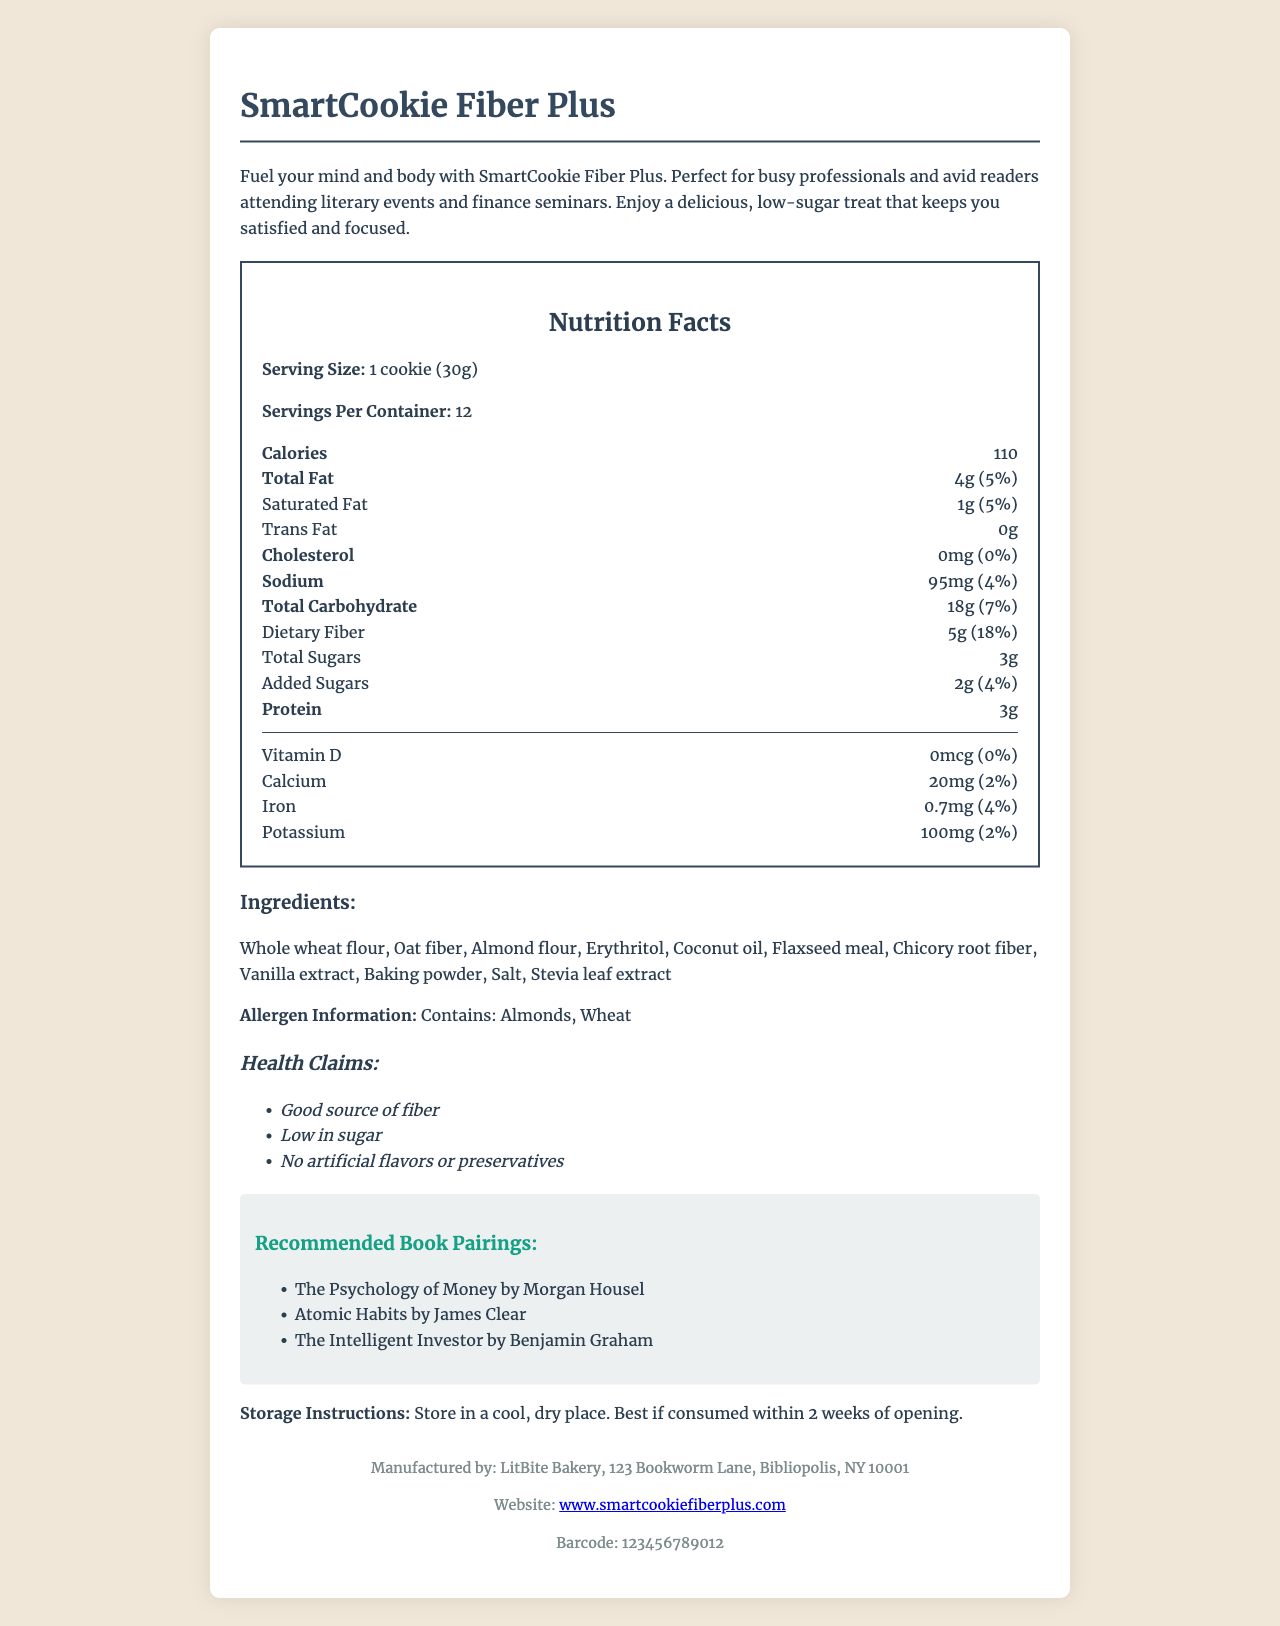what is the serving size of SmartCookie Fiber Plus? The serving size is specified as "1 cookie (30g)" in the nutrition label section of the document.
Answer: 1 cookie (30g) how many servings per container are there? The document indicates there are 12 servings per container.
Answer: 12 how many calories are in one serving of SmartCookie Fiber Plus? The nutrition label states that there are 110 calories per serving.
Answer: 110 what is the total amount of dietary fiber in one cookie? The nutrition label specifies that each serving contains 5g of dietary fiber.
Answer: 5g what percentage of the daily value for dietary fiber does one serving provide? The document shows that one serving provides 18% of the daily value for dietary fiber.
Answer: 18% what is the amount of total sugars in one cookie? The nutrition label lists the total sugars content as 3g per serving.
Answer: 3g how much added sugar does one serving of SmartCookie Fiber Plus contain? According to the nutrition label, there are 2g of added sugars per serving.
Answer: 2g what are the main ingredients in SmartCookie Fiber Plus? The document lists the main ingredients in the ingredients section.
Answer: Whole wheat flour, Oat fiber, Almond flour, Erythritol, Coconut oil, Flaxseed meal, Chicory root fiber, Vanilla extract, Baking powder, Salt, Stevia leaf extract which of the following books is recommended to pair with SmartCookie Fiber Plus? A. The Intelligent Investor B. Harry Potter and the Sorcerer’s Stone C. The Great Gatsby The document provides a list of recommended book pairings, which includes "The Intelligent Investor".
Answer: A what is the recommended storage instruction for SmartCookie Fiber Plus? A. Refrigerate B. Freeze C. Store in a cool, dry place D. Keep at room temperature The document states to "Store in a cool, dry place.”
Answer: C is SmartCookie Fiber Plus low in cholesterol? The nutrition label indicates that the amount of cholesterol is 0mg, which corresponds to 0% of the daily value.
Answer: Yes how long is SmartCookie Fiber Plus good after opening? The storage instructions specify that it is best if consumed within 2 weeks of opening.
Answer: 2 weeks who manufactures SmartCookie Fiber Plus? The document states that the manufacturer is LitBite Bakery, located at 123 Bookworm Lane, Bibliopolis, NY 10001.
Answer: LitBite Bakery summarize the main idea of the document. The document contains various sections providing comprehensive details about the product, focusing on its nutritional benefits, ingredients, storage and consumption, and pairing suggestions.
Answer: The document provides detailed information about SmartCookie Fiber Plus, a low-sugar, high-fiber cookie. It includes the nutrition facts, ingredient list, health claims, storage instructions, recommended book pairings, and manufacturer details. It is marketed as a healthy snack for busy professionals and readers. what are the health claims mentioned for SmartCookie Fiber Plus? The document lists the health claims under the health claims section.
Answer: Good source of fiber, Low in sugar, No artificial flavors or preservatives what is the website for more information about SmartCookie Fiber Plus? The footer of the document provides the website "www.smartcookiefiberplus.com" for more information.
Answer: www.smartcookiefiberplus.com does SmartCookie Fiber Plus contain peanuts? The document does not mention peanuts specifically; it states that the product contains almonds and wheat.
Answer: Cannot be determined how much protein is in one cookie? The nutrition label specifies that each serving contains 3g of protein.
Answer: 3g 